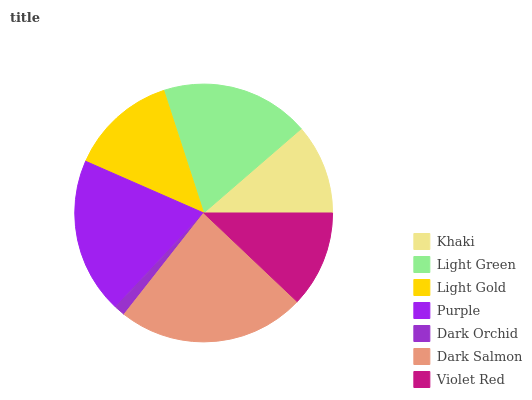Is Dark Orchid the minimum?
Answer yes or no. Yes. Is Dark Salmon the maximum?
Answer yes or no. Yes. Is Light Green the minimum?
Answer yes or no. No. Is Light Green the maximum?
Answer yes or no. No. Is Light Green greater than Khaki?
Answer yes or no. Yes. Is Khaki less than Light Green?
Answer yes or no. Yes. Is Khaki greater than Light Green?
Answer yes or no. No. Is Light Green less than Khaki?
Answer yes or no. No. Is Light Gold the high median?
Answer yes or no. Yes. Is Light Gold the low median?
Answer yes or no. Yes. Is Khaki the high median?
Answer yes or no. No. Is Dark Orchid the low median?
Answer yes or no. No. 